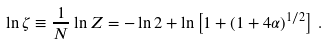Convert formula to latex. <formula><loc_0><loc_0><loc_500><loc_500>\ln \zeta \equiv \frac { 1 } { N } \ln Z = - \ln 2 + \ln \left [ 1 + \left ( 1 + 4 \alpha \right ) ^ { 1 / 2 } \right ] \, .</formula> 